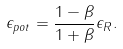Convert formula to latex. <formula><loc_0><loc_0><loc_500><loc_500>\epsilon _ { p o t } = \frac { 1 - \beta } { 1 + \beta } \epsilon _ { R } .</formula> 